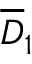<formula> <loc_0><loc_0><loc_500><loc_500>\overline { D } _ { 1 }</formula> 